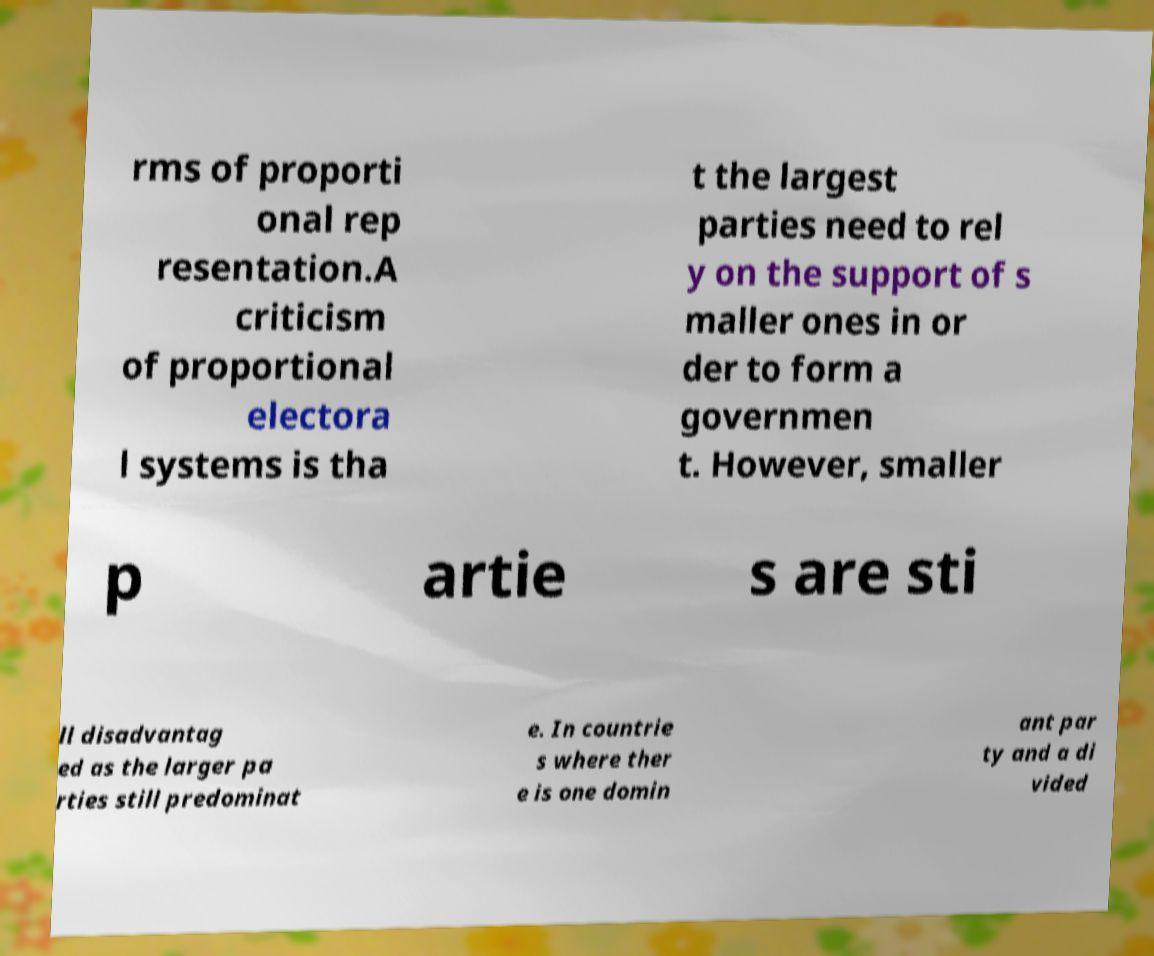Can you accurately transcribe the text from the provided image for me? rms of proporti onal rep resentation.A criticism of proportional electora l systems is tha t the largest parties need to rel y on the support of s maller ones in or der to form a governmen t. However, smaller p artie s are sti ll disadvantag ed as the larger pa rties still predominat e. In countrie s where ther e is one domin ant par ty and a di vided 